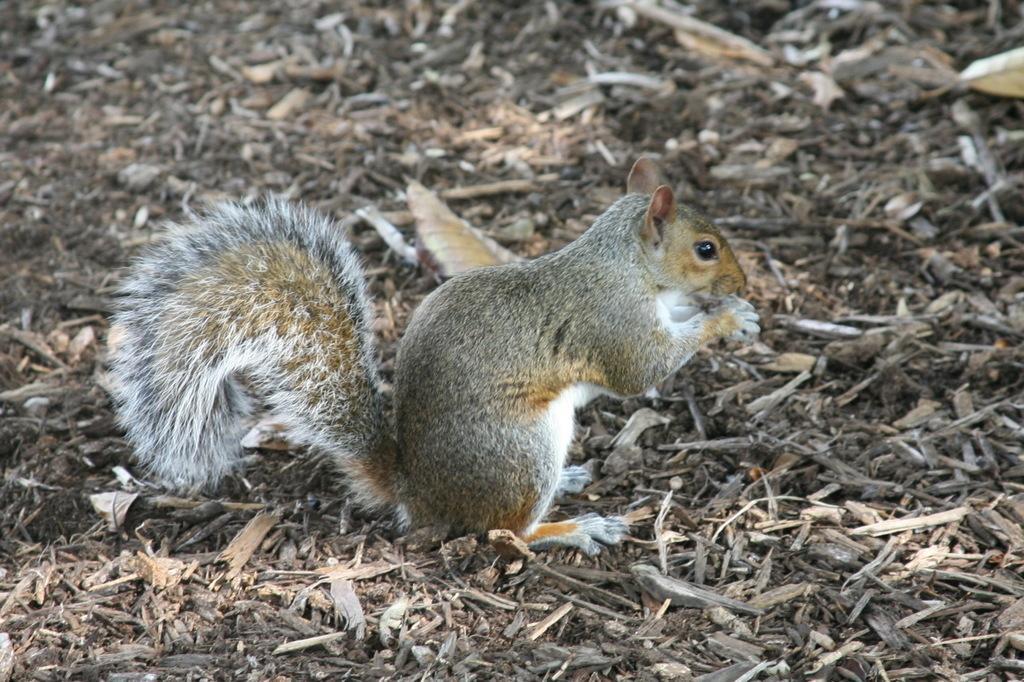In one or two sentences, can you explain what this image depicts? This picture shows a squirrel on the ground. It is white, brown and grey in color and we see wooden pieces on the ground. 